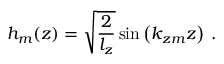Convert formula to latex. <formula><loc_0><loc_0><loc_500><loc_500>h _ { m } ( z ) = \sqrt { \frac { 2 } { l _ { z } } } \sin \left ( k _ { z m } z \right ) \, .</formula> 